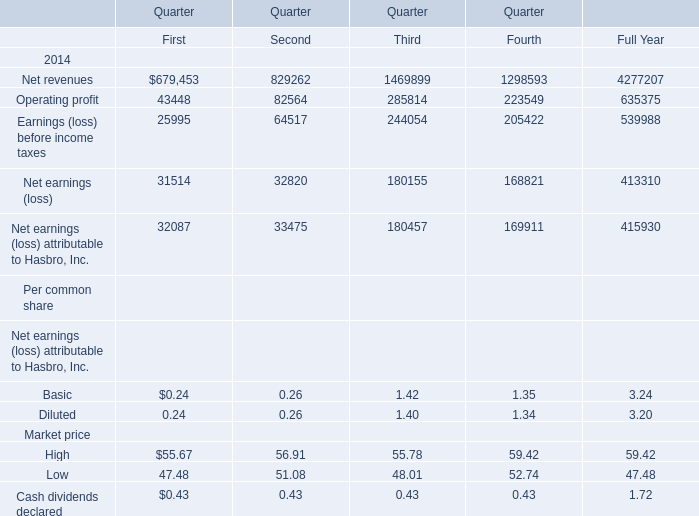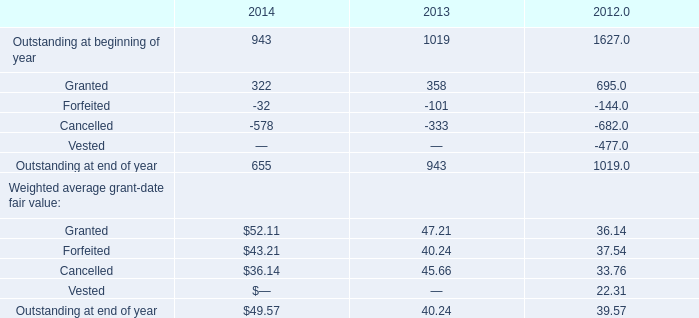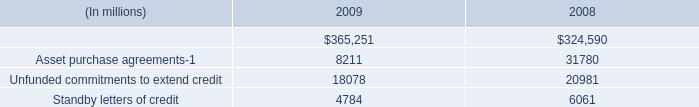what is the percent change in asset purchase agreements between 2008 and 2009? 
Computations: ((8211 - 31780) / 31780)
Answer: -0.74163. 